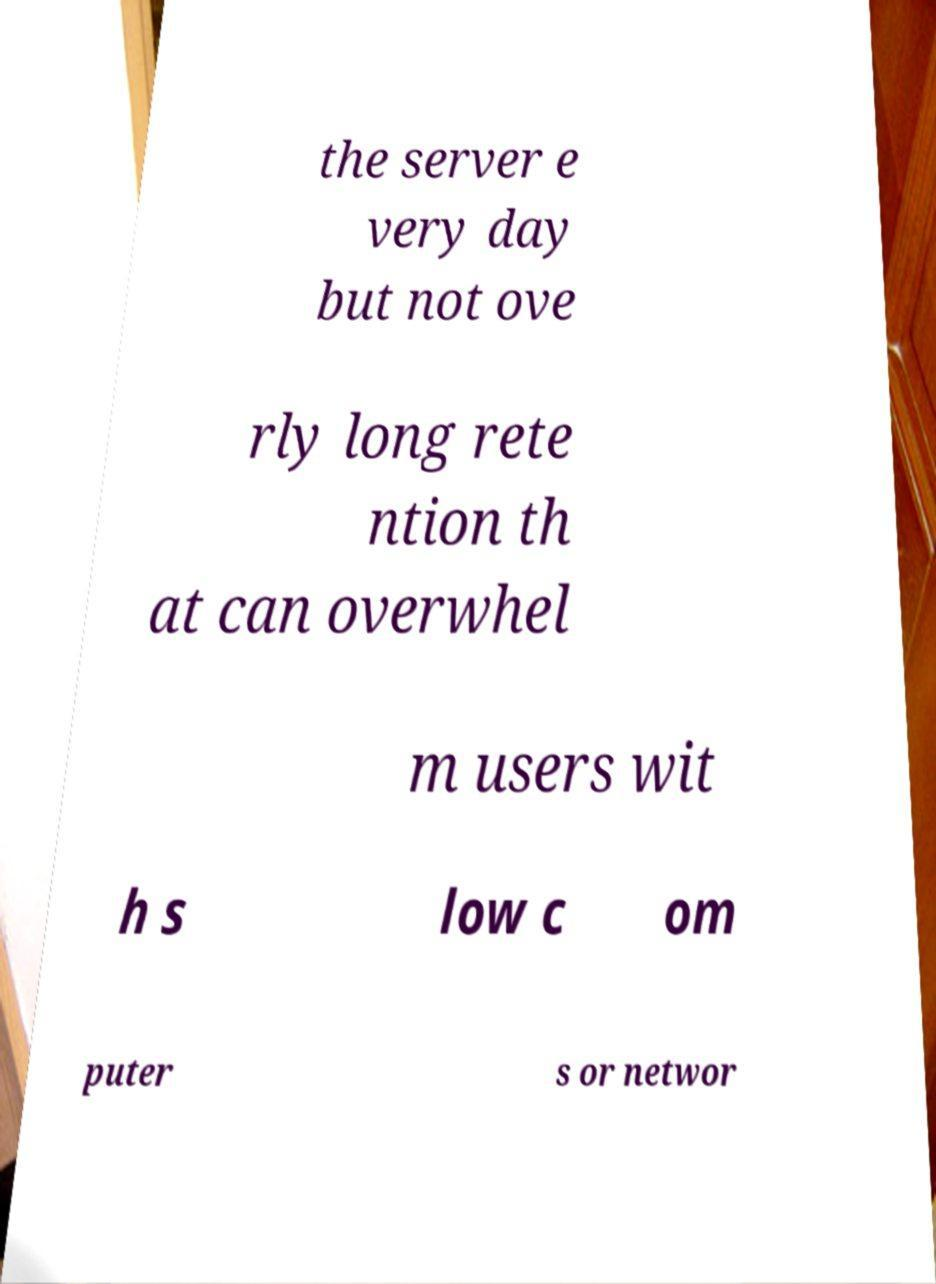For documentation purposes, I need the text within this image transcribed. Could you provide that? the server e very day but not ove rly long rete ntion th at can overwhel m users wit h s low c om puter s or networ 